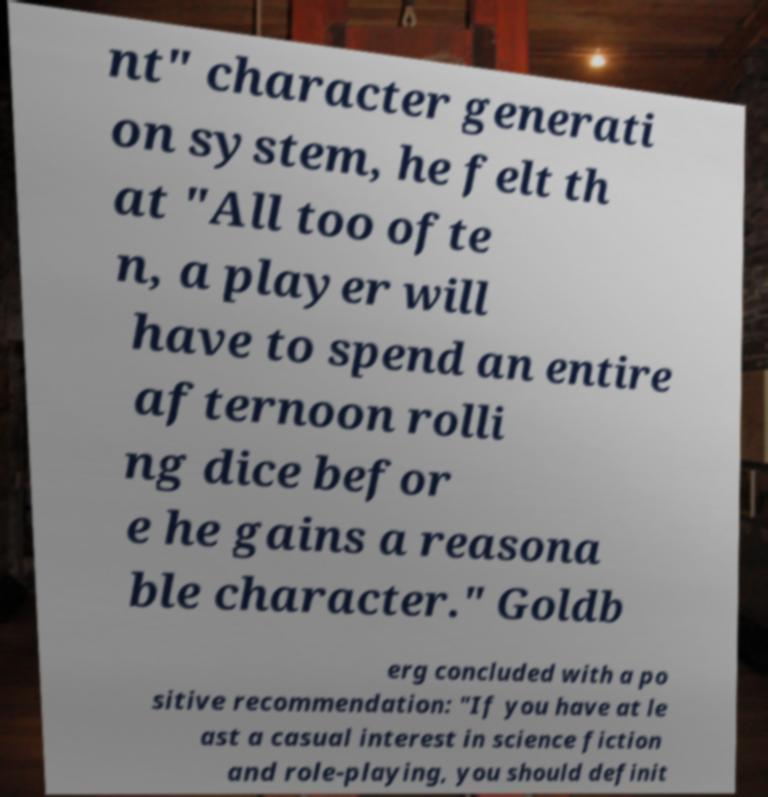Can you accurately transcribe the text from the provided image for me? nt" character generati on system, he felt th at "All too ofte n, a player will have to spend an entire afternoon rolli ng dice befor e he gains a reasona ble character." Goldb erg concluded with a po sitive recommendation: "If you have at le ast a casual interest in science fiction and role-playing, you should definit 